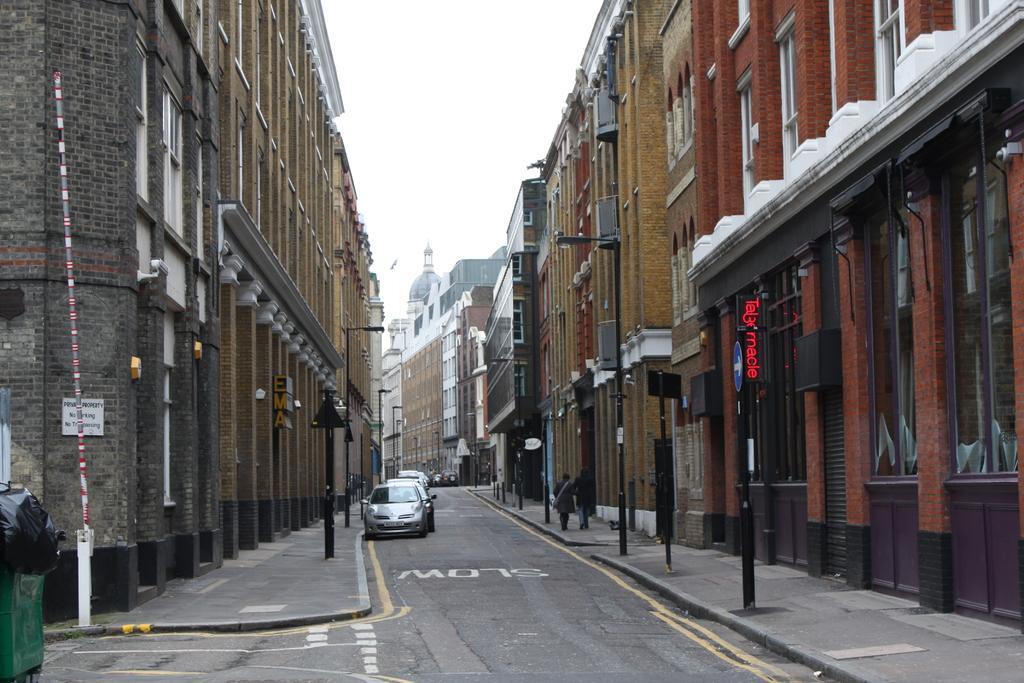How would you summarize this image in a sentence or two? In the foreground of this image, there is a road on which there are vehicles. On either side, there are poles and buildings. On the right, there are two people walking on the side path. At the top, there is the sky. 